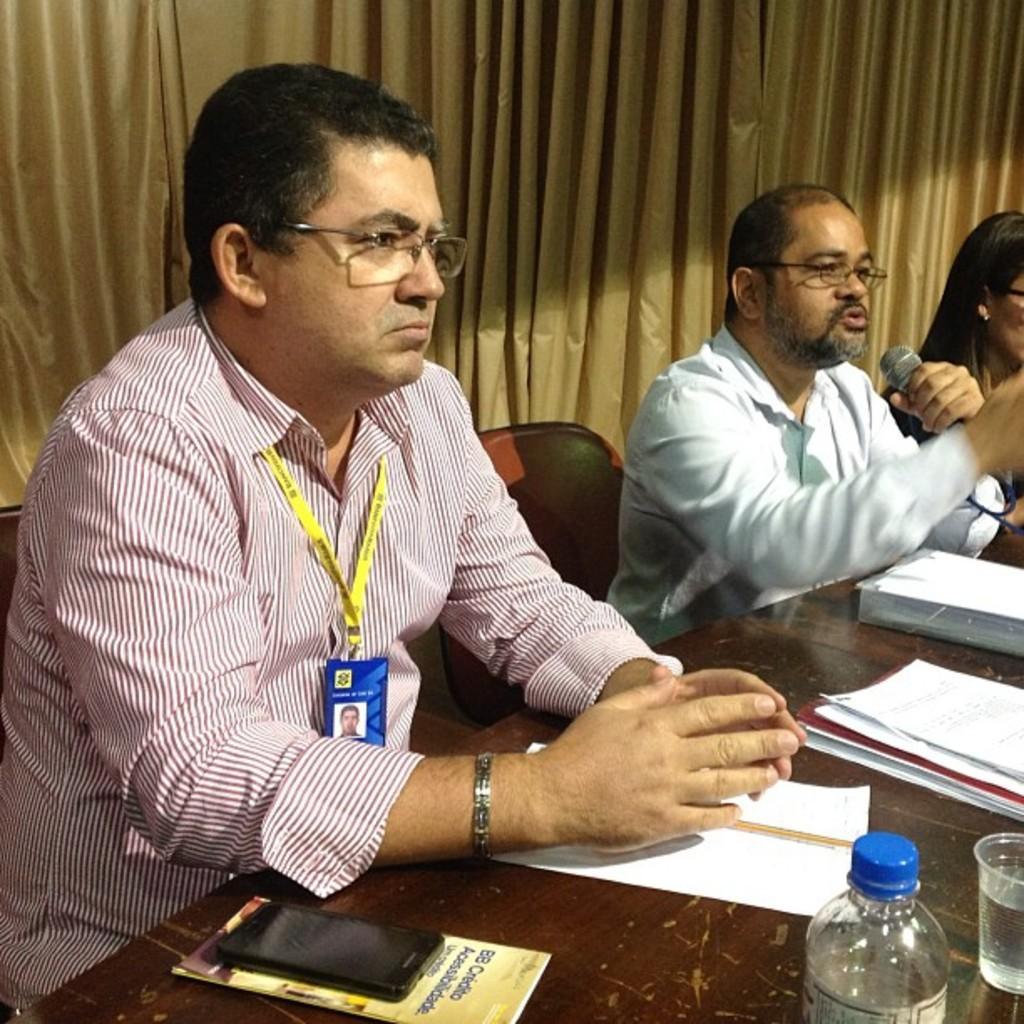In one or two sentences, can you explain what this image depicts? In the center of the image we can see people sitting. The man sitting on the right is holding a mic in his hand, before them there is a table and we can see books, papers, mobile, bottle and a glass placed on the table. In the background there is a curtain. 